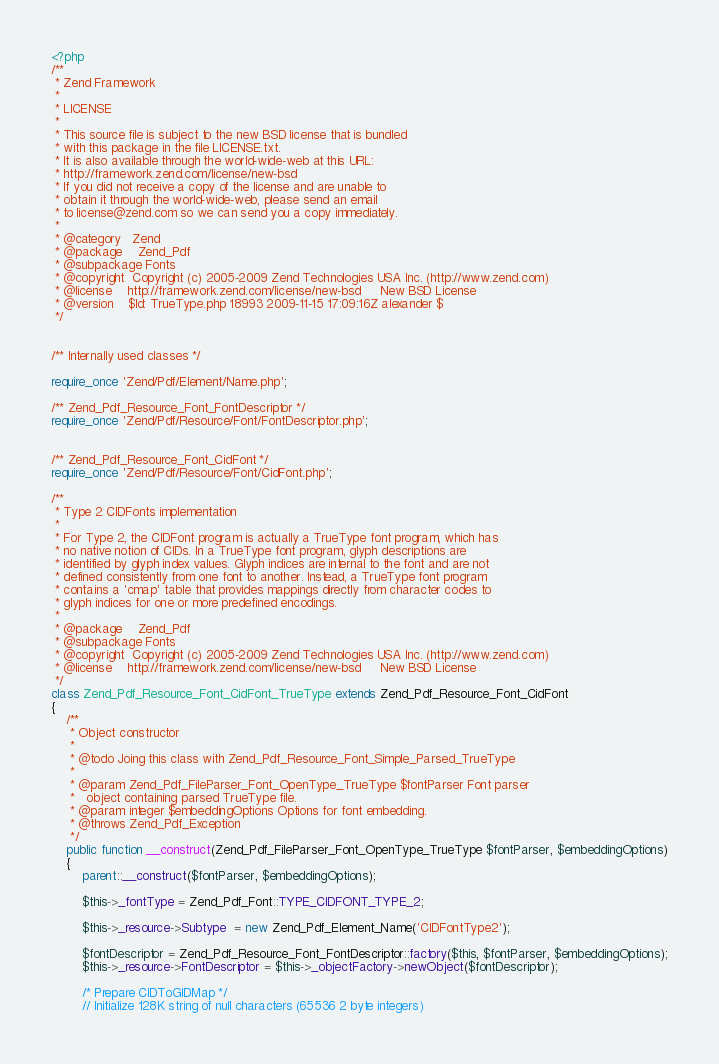<code> <loc_0><loc_0><loc_500><loc_500><_PHP_><?php
/**
 * Zend Framework
 *
 * LICENSE
 *
 * This source file is subject to the new BSD license that is bundled
 * with this package in the file LICENSE.txt.
 * It is also available through the world-wide-web at this URL:
 * http://framework.zend.com/license/new-bsd
 * If you did not receive a copy of the license and are unable to
 * obtain it through the world-wide-web, please send an email
 * to license@zend.com so we can send you a copy immediately.
 *
 * @category   Zend
 * @package    Zend_Pdf
 * @subpackage Fonts
 * @copyright  Copyright (c) 2005-2009 Zend Technologies USA Inc. (http://www.zend.com)
 * @license    http://framework.zend.com/license/new-bsd     New BSD License
 * @version    $Id: TrueType.php 18993 2009-11-15 17:09:16Z alexander $
 */


/** Internally used classes */

require_once 'Zend/Pdf/Element/Name.php';

/** Zend_Pdf_Resource_Font_FontDescriptor */
require_once 'Zend/Pdf/Resource/Font/FontDescriptor.php';


/** Zend_Pdf_Resource_Font_CidFont */
require_once 'Zend/Pdf/Resource/Font/CidFont.php';

/**
 * Type 2 CIDFonts implementation
 *
 * For Type 2, the CIDFont program is actually a TrueType font program, which has
 * no native notion of CIDs. In a TrueType font program, glyph descriptions are
 * identified by glyph index values. Glyph indices are internal to the font and are not
 * defined consistently from one font to another. Instead, a TrueType font program
 * contains a 'cmap' table that provides mappings directly from character codes to
 * glyph indices for one or more predefined encodings.
 *
 * @package    Zend_Pdf
 * @subpackage Fonts
 * @copyright  Copyright (c) 2005-2009 Zend Technologies USA Inc. (http://www.zend.com)
 * @license    http://framework.zend.com/license/new-bsd     New BSD License
 */
class Zend_Pdf_Resource_Font_CidFont_TrueType extends Zend_Pdf_Resource_Font_CidFont
{
    /**
     * Object constructor
     *
     * @todo Joing this class with Zend_Pdf_Resource_Font_Simple_Parsed_TrueType
     *
     * @param Zend_Pdf_FileParser_Font_OpenType_TrueType $fontParser Font parser
     *   object containing parsed TrueType file.
     * @param integer $embeddingOptions Options for font embedding.
     * @throws Zend_Pdf_Exception
     */
    public function __construct(Zend_Pdf_FileParser_Font_OpenType_TrueType $fontParser, $embeddingOptions)
    {
        parent::__construct($fontParser, $embeddingOptions);

        $this->_fontType = Zend_Pdf_Font::TYPE_CIDFONT_TYPE_2;

        $this->_resource->Subtype  = new Zend_Pdf_Element_Name('CIDFontType2');

        $fontDescriptor = Zend_Pdf_Resource_Font_FontDescriptor::factory($this, $fontParser, $embeddingOptions);
        $this->_resource->FontDescriptor = $this->_objectFactory->newObject($fontDescriptor);

        /* Prepare CIDToGIDMap */
        // Initialize 128K string of null characters (65536 2 byte integers)</code> 